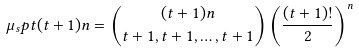Convert formula to latex. <formula><loc_0><loc_0><loc_500><loc_500>\mu _ { s } p t { ( t + 1 ) n } = \binom { ( t + 1 ) n } { t + 1 , t + 1 , \dots , t + 1 } \left ( \frac { ( t + 1 ) ! } { 2 } \right ) ^ { n }</formula> 